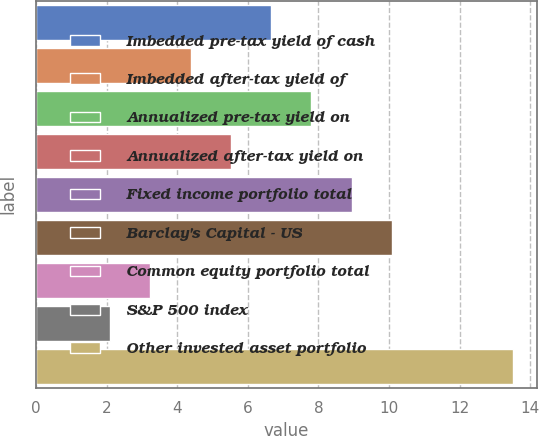Convert chart. <chart><loc_0><loc_0><loc_500><loc_500><bar_chart><fcel>Imbedded pre-tax yield of cash<fcel>Imbedded after-tax yield of<fcel>Annualized pre-tax yield on<fcel>Annualized after-tax yield on<fcel>Fixed income portfolio total<fcel>Barclay's Capital - US<fcel>Common equity portfolio total<fcel>S&P 500 index<fcel>Other invested asset portfolio<nl><fcel>6.66<fcel>4.38<fcel>7.8<fcel>5.52<fcel>8.94<fcel>10.08<fcel>3.24<fcel>2.1<fcel>13.5<nl></chart> 